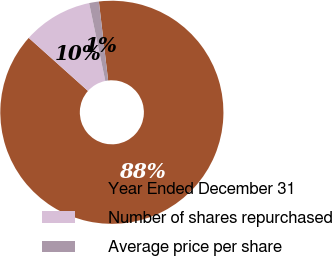Convert chart. <chart><loc_0><loc_0><loc_500><loc_500><pie_chart><fcel>Year Ended December 31<fcel>Number of shares repurchased<fcel>Average price per share<nl><fcel>88.48%<fcel>10.11%<fcel>1.41%<nl></chart> 